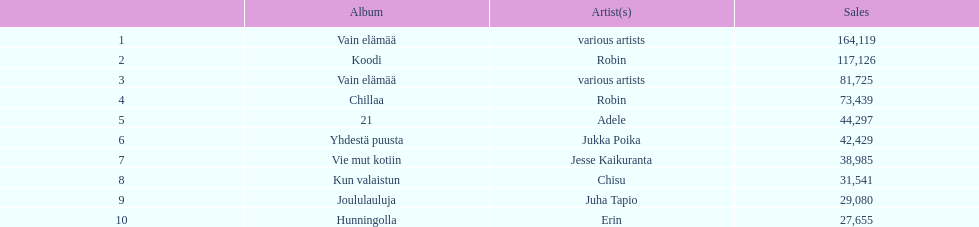Tell me an album that had the same artist as chillaa. Koodi. 